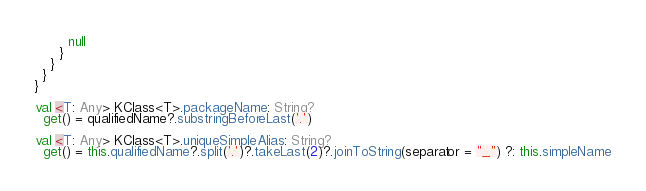Convert code to text. <code><loc_0><loc_0><loc_500><loc_500><_Kotlin_>        null
      }
    }
  }
}

val <T: Any> KClass<T>.packageName: String?
  get() = qualifiedName?.substringBeforeLast('.')

val <T: Any> KClass<T>.uniqueSimpleAlias: String?
  get() = this.qualifiedName?.split('.')?.takeLast(2)?.joinToString(separator = "_") ?: this.simpleName
</code> 